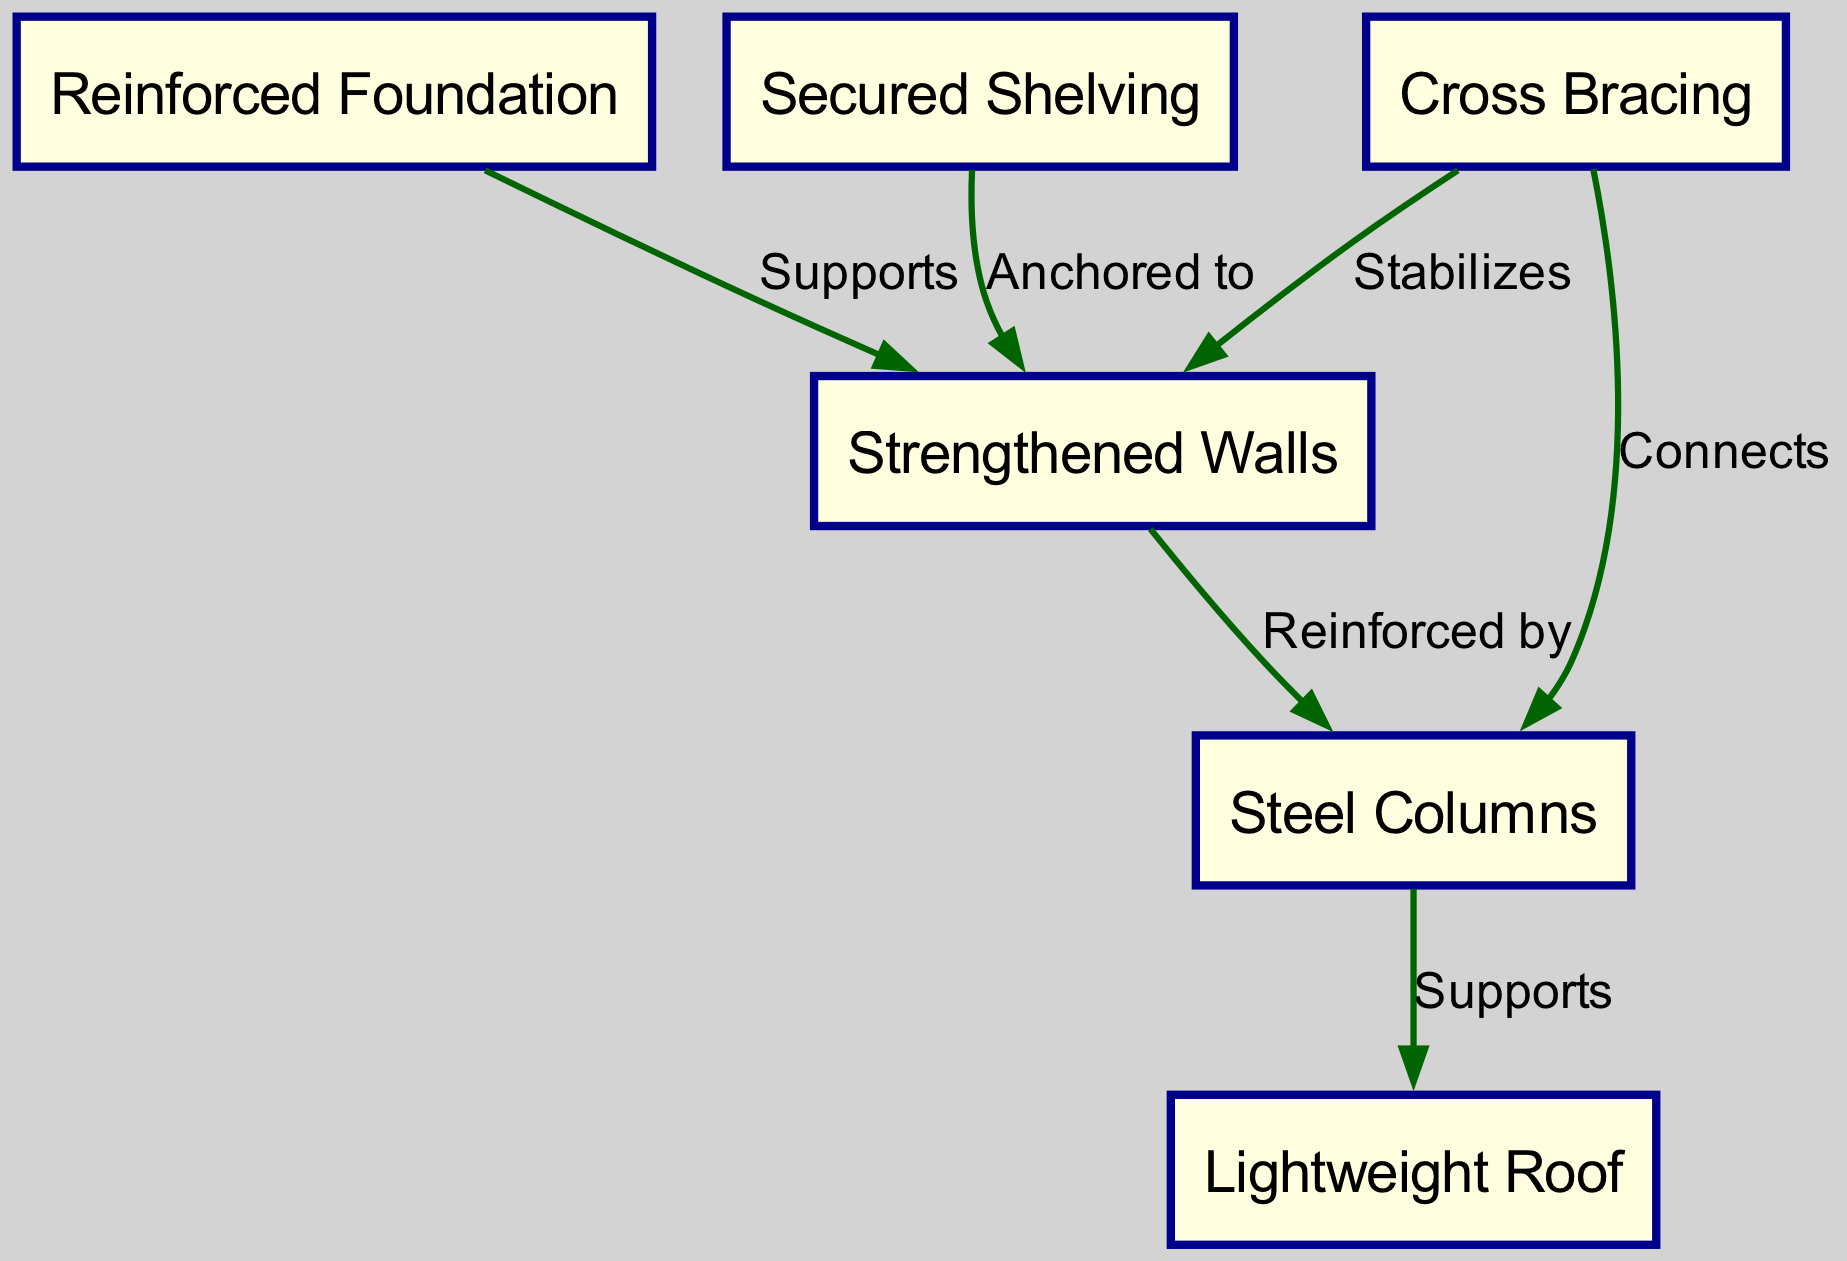What is the first node in the diagram? The first node in the diagram is "Reinforced Foundation," which can be identified as the starting point for other components listed in the diagram.
Answer: Reinforced Foundation How many nodes are present in the diagram? There are six nodes present: Reinforced Foundation, Strengthened Walls, Steel Columns, Lightweight Roof, Cross Bracing, and Secured Shelving.
Answer: 6 What does the "Cross Bracing" node do for the "Walls"? The "Cross Bracing" node is labeled as "Stabilizes" in relation to the "Walls," showing that it provides a stabilization function to them in the context of earthquake resistance.
Answer: Stabilizes Which node is reinforced by the "Walls"? The node "Steel Columns" is reinforced by the "Walls" as indicated in the edge labeled "Reinforced by," which highlights an important structural reinforcement relationship in the diagram.
Answer: Steel Columns What supports the "Lightweight Roof"? The "Steel Columns" node supports the "Lightweight Roof," demonstrating the structural hierarchy between vertical and horizontal elements in the building's design.
Answer: Steel Columns How are the "Secured Shelving" anchored in the diagram? "Secured Shelving" is anchored to the "Walls," as indicated by the edge labeled "Anchored to," establishing a connection essential for safety during an earthquake.
Answer: Anchored to Which components connect "Cross Bracing"? "Cross Bracing" connects both the "Walls" and the "Steel Columns," reflected in the edges labeled "Connects," indicating its role in linking these two structural elements for stability.
Answer: Walls, Steel Columns What does the "Lightweight Roof" depend on for structural integrity? The "Lightweight Roof" depends on the "Steel Columns" for structural integrity, as shown by the edge labeled "Supports," meaning it relies on the columns' strength.
Answer: Steel Columns 